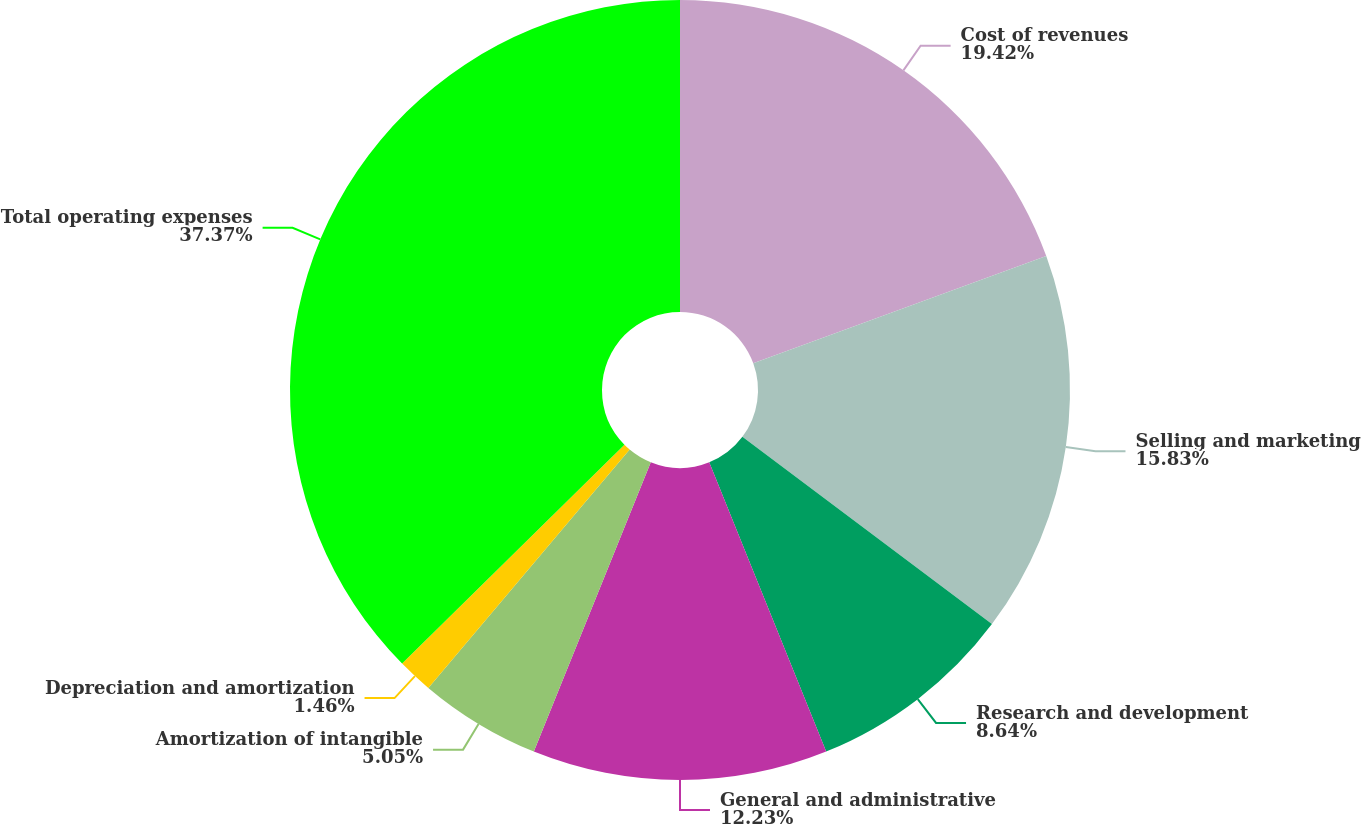<chart> <loc_0><loc_0><loc_500><loc_500><pie_chart><fcel>Cost of revenues<fcel>Selling and marketing<fcel>Research and development<fcel>General and administrative<fcel>Amortization of intangible<fcel>Depreciation and amortization<fcel>Total operating expenses<nl><fcel>19.42%<fcel>15.83%<fcel>8.64%<fcel>12.23%<fcel>5.05%<fcel>1.46%<fcel>37.38%<nl></chart> 